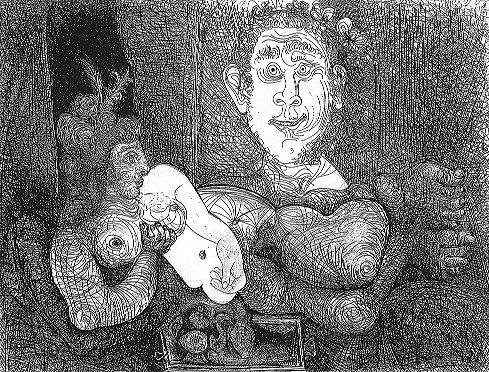What are the key elements in this picture? The artwork is a detailed black and white etching that evokes the surrealistic styles reminiscent of artists like Salvador Dali. Central to the composition is a figure with an oversized head and a smaller body, holding a card with the number 6. To the left of this figure, there is a bizarre creature blending avian and human characteristics, enhancing the surreal quality of the piece. On the right, a small canine-like creature with a human face adds to this unusual tableau. The background and surroundings are intricately detailed with patterns and elements that contribute to the overall enigmatic and fantastical atmosphere of the work. 